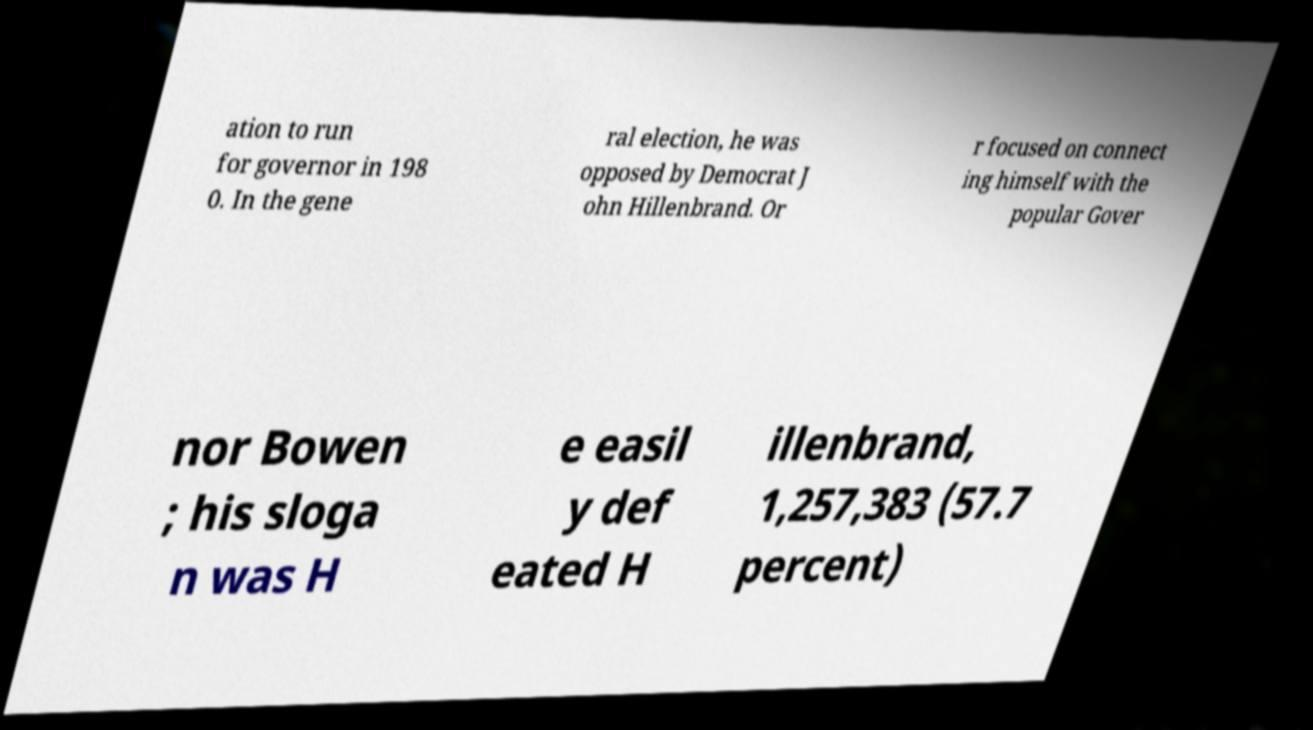Can you accurately transcribe the text from the provided image for me? ation to run for governor in 198 0. In the gene ral election, he was opposed by Democrat J ohn Hillenbrand. Or r focused on connect ing himself with the popular Gover nor Bowen ; his sloga n was H e easil y def eated H illenbrand, 1,257,383 (57.7 percent) 